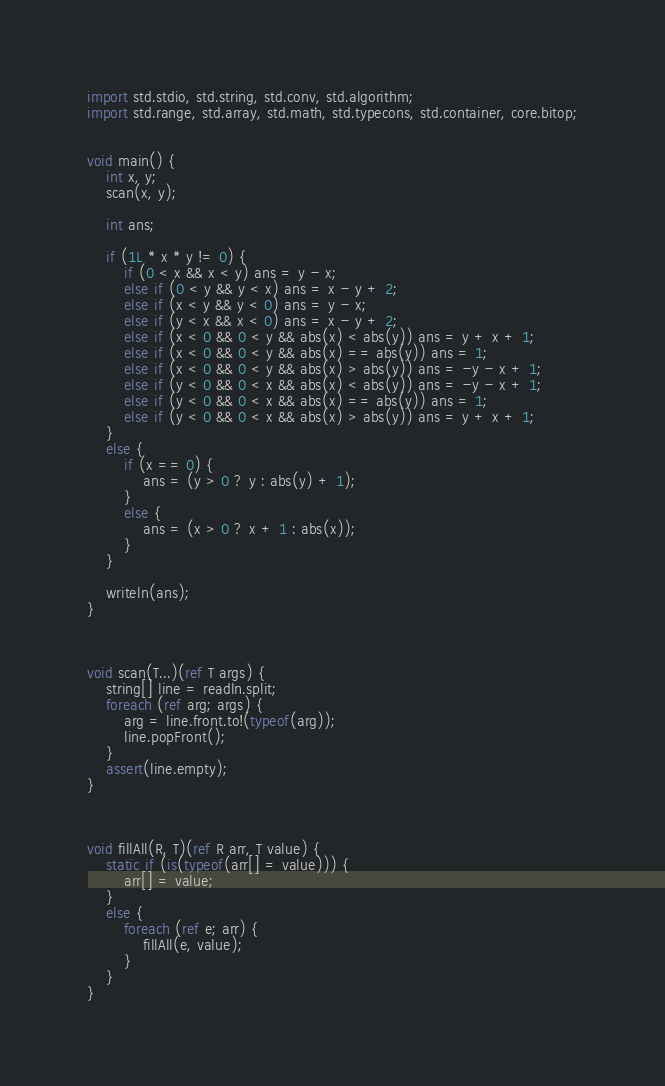<code> <loc_0><loc_0><loc_500><loc_500><_D_>import std.stdio, std.string, std.conv, std.algorithm;
import std.range, std.array, std.math, std.typecons, std.container, core.bitop;


void main() {
    int x, y;
    scan(x, y);

    int ans;

    if (1L * x * y != 0) {
        if (0 < x && x < y) ans = y - x;
        else if (0 < y && y < x) ans = x - y + 2;
        else if (x < y && y < 0) ans = y - x;
        else if (y < x && x < 0) ans = x - y + 2;
        else if (x < 0 && 0 < y && abs(x) < abs(y)) ans = y + x + 1;
        else if (x < 0 && 0 < y && abs(x) == abs(y)) ans = 1;
        else if (x < 0 && 0 < y && abs(x) > abs(y)) ans = -y - x + 1;
        else if (y < 0 && 0 < x && abs(x) < abs(y)) ans = -y - x + 1;
        else if (y < 0 && 0 < x && abs(x) == abs(y)) ans = 1;
        else if (y < 0 && 0 < x && abs(x) > abs(y)) ans = y + x + 1;
    }
    else {
        if (x == 0) {
            ans = (y > 0 ? y : abs(y) + 1);
        }
        else {
            ans = (x > 0 ? x + 1 : abs(x));
        }
    }

    writeln(ans);
}



void scan(T...)(ref T args) {
    string[] line = readln.split;
    foreach (ref arg; args) {
        arg = line.front.to!(typeof(arg));
        line.popFront();
    }
    assert(line.empty);
}



void fillAll(R, T)(ref R arr, T value) {
    static if (is(typeof(arr[] = value))) {
        arr[] = value;
    }
    else {
        foreach (ref e; arr) {
            fillAll(e, value);
        }
    }
}</code> 